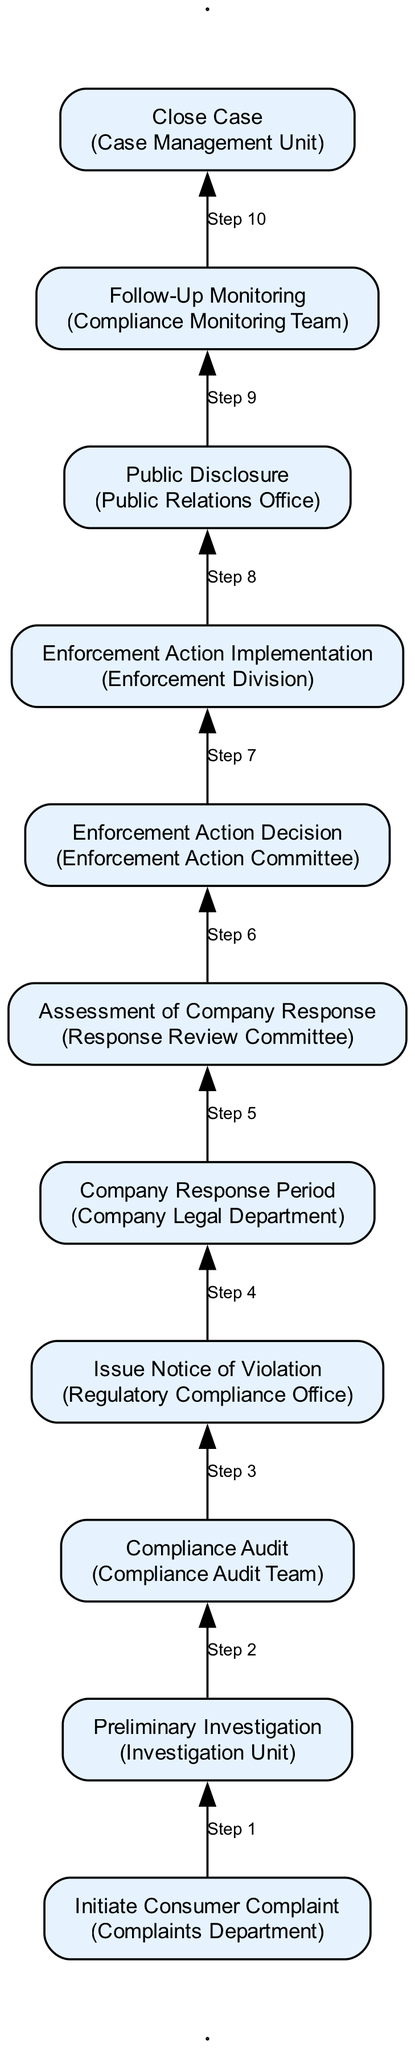What's the first step in the enforcement process? The first step is "Initiate Consumer Complaint," which involves receiving and documenting complaints from consumers about price violations.
Answer: Initiate Consumer Complaint How many total steps are in the regulation enforcement process? There are a total of 11 steps in the enforcement process, starting from consumer complaints and ending with case closure.
Answer: 11 What entity is responsible for the "Compliance Audit"? The entity responsible for the "Compliance Audit" is the "Compliance Audit Team."
Answer: Compliance Audit Team Which step follows the "Assessment of Company Response"? The step that follows "Assessment of Company Response" is "Enforcement Action Decision," where the appropriate action based on the assessment is made.
Answer: Enforcement Action Decision How many entities are involved in the process? There are 11 different entities involved in the enforcement process corresponding to each step in the flowchart.
Answer: 11 What is the purpose of the "Public Disclosure" step? The purpose of the "Public Disclosure" step is to publicize enforcement actions, ensuring transparency and informing consumers about regulatory actions taken against companies.
Answer: Publicize enforcement actions Which step requires the company's legal department to act? The "Company Response Period" requires the company's legal department to respond to the notice and rectify the issues within a specified period.
Answer: Company Response Period After which step is the case considered for closure? The case is considered for closure after the "Follow-Up Monitoring" step, provided the company complies with all required actions.
Answer: Follow-Up Monitoring Which committee is responsible for evaluating the company's response? The "Response Review Committee" is responsible for evaluating the company's response and its corrective measures after receiving the notice of violation.
Answer: Response Review Committee What happens during "Enforcement Action Implementation"? During "Enforcement Action Implementation," the decided enforcement actions, such as fines or penalties, are carried out against the company.
Answer: Implement enforcement actions 